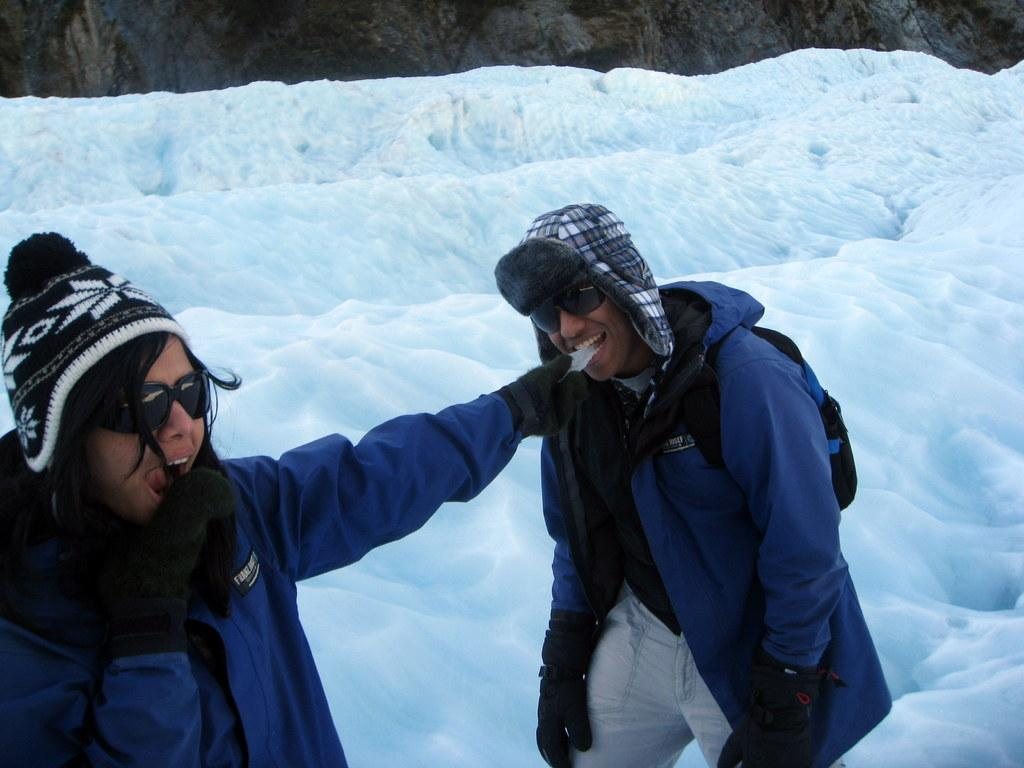How many people are in the image? There are two people in the image, a man and a woman. What are the man and woman wearing? The man and woman are both wearing jackets, gloves, goggles, and caps. What can be observed about the jackets they are wearing? The jackets are of a similar color. What is the background of the image? There is snow in the background of the image. Who is the creator of the snow in the image? The image does not provide information about the creator of the snow; it is a natural occurrence in the background. What type of club can be seen in the hands of the man and woman in the image? There are no clubs visible in the hands of the man and woman in the image. 